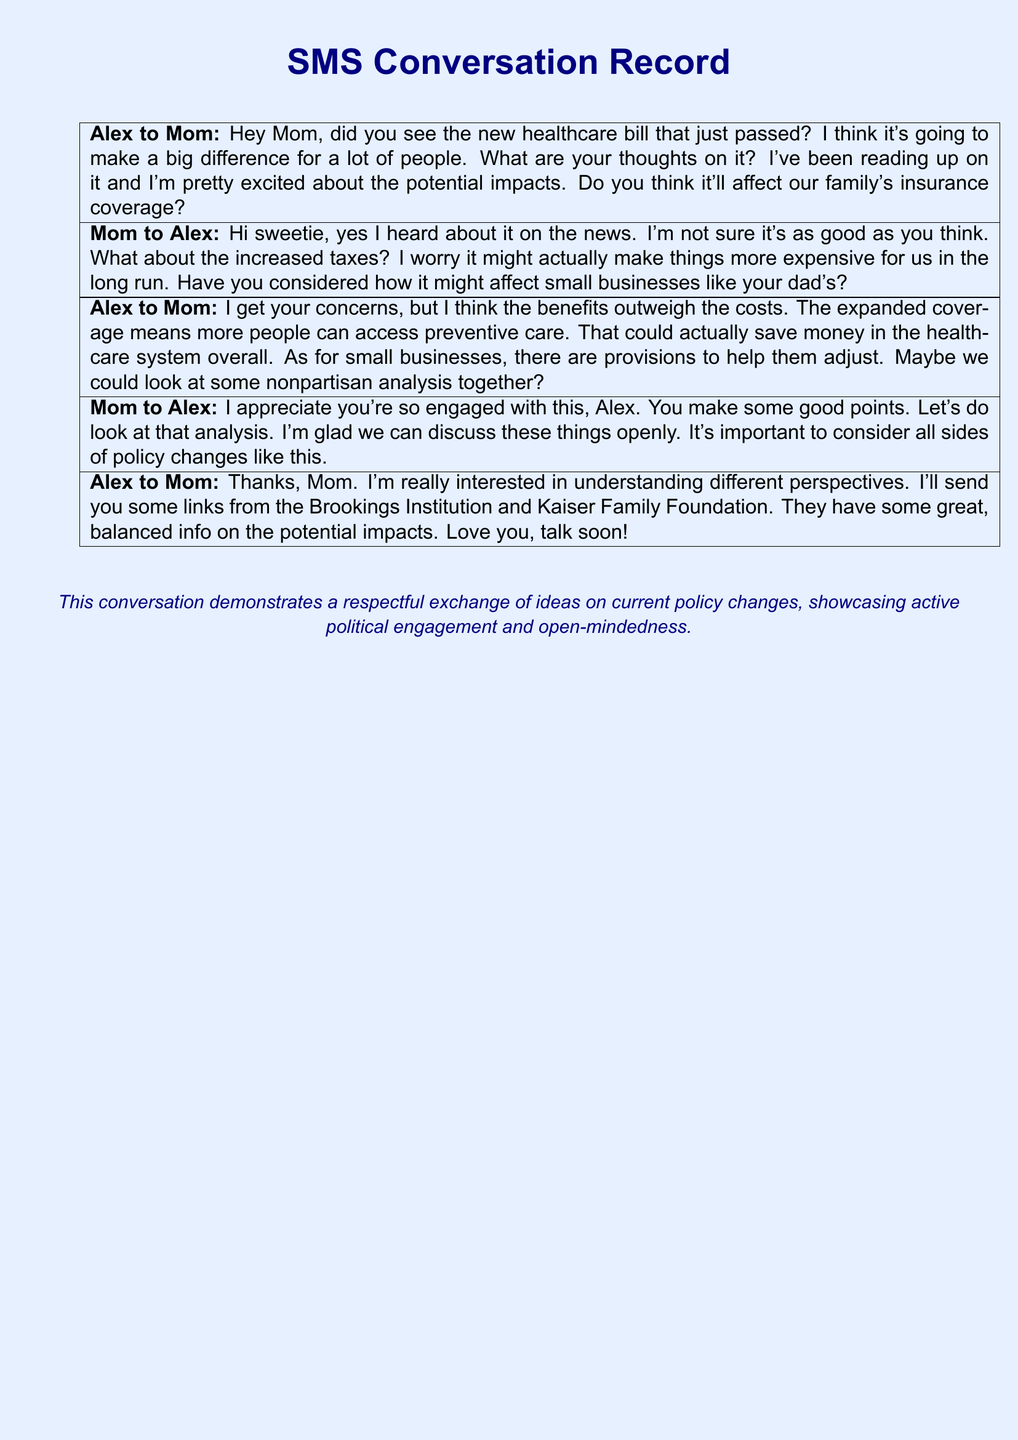What is the name of the healthcare bill mentioned? The healthcare bill discussed in the conversation contributes to the overall context but is not specifically named in the document.
Answer: Not specified Who is concerned about increased taxes? The concern regarding increased taxes was expressed by Mom in the conversation.
Answer: Mom What institution did Alex refer to for analysis? Alex indicated sending links from the Brookings Institution and Kaiser Family Foundation for balanced information.
Answer: Brookings Institution and Kaiser Family Foundation What is Mom's relationship with Alex? The document indicates a familial relationship characterized by endearment and open discussion.
Answer: Mom What does Alex think the healthcare bill will do? Alex believes the new healthcare bill will make a big difference for many people, particularly through expanded access.
Answer: Make a big difference How does Mom feel about the discussion? Mom expresses appreciation for Alex's engagement with political issues and is glad they can discuss them openly.
Answer: Appreciative What type of care does Alex mention could be accessed more? Alex mentions that the healthcare bill will allow more people to access preventive care.
Answer: Preventive care What does Alex plan to do after the conversation? Alex plans to send links that provide information about the healthcare bill.
Answer: Send links What is the tone of the overall conversation? The conversation showcases a respectful exchange of ideas on political discourse and policy changes.
Answer: Respectful 